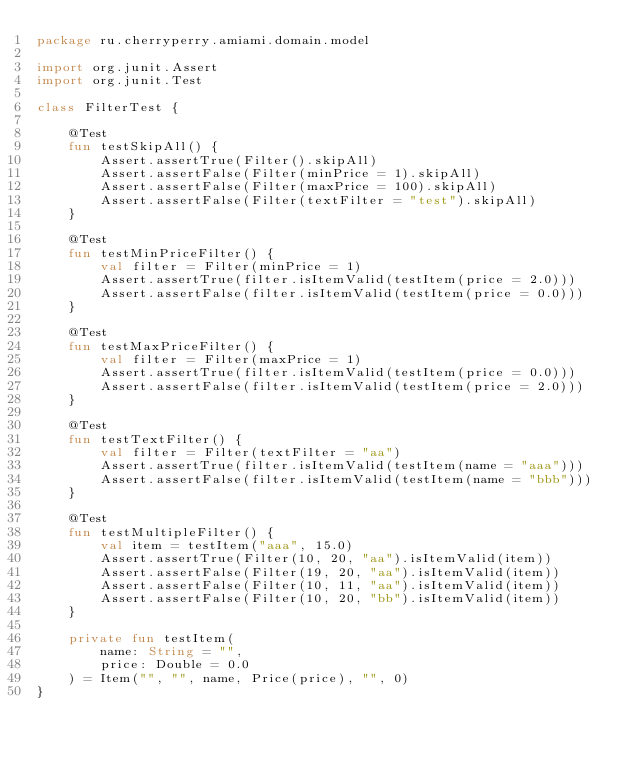Convert code to text. <code><loc_0><loc_0><loc_500><loc_500><_Kotlin_>package ru.cherryperry.amiami.domain.model

import org.junit.Assert
import org.junit.Test

class FilterTest {

    @Test
    fun testSkipAll() {
        Assert.assertTrue(Filter().skipAll)
        Assert.assertFalse(Filter(minPrice = 1).skipAll)
        Assert.assertFalse(Filter(maxPrice = 100).skipAll)
        Assert.assertFalse(Filter(textFilter = "test").skipAll)
    }

    @Test
    fun testMinPriceFilter() {
        val filter = Filter(minPrice = 1)
        Assert.assertTrue(filter.isItemValid(testItem(price = 2.0)))
        Assert.assertFalse(filter.isItemValid(testItem(price = 0.0)))
    }

    @Test
    fun testMaxPriceFilter() {
        val filter = Filter(maxPrice = 1)
        Assert.assertTrue(filter.isItemValid(testItem(price = 0.0)))
        Assert.assertFalse(filter.isItemValid(testItem(price = 2.0)))
    }

    @Test
    fun testTextFilter() {
        val filter = Filter(textFilter = "aa")
        Assert.assertTrue(filter.isItemValid(testItem(name = "aaa")))
        Assert.assertFalse(filter.isItemValid(testItem(name = "bbb")))
    }

    @Test
    fun testMultipleFilter() {
        val item = testItem("aaa", 15.0)
        Assert.assertTrue(Filter(10, 20, "aa").isItemValid(item))
        Assert.assertFalse(Filter(19, 20, "aa").isItemValid(item))
        Assert.assertFalse(Filter(10, 11, "aa").isItemValid(item))
        Assert.assertFalse(Filter(10, 20, "bb").isItemValid(item))
    }

    private fun testItem(
        name: String = "",
        price: Double = 0.0
    ) = Item("", "", name, Price(price), "", 0)
}
</code> 